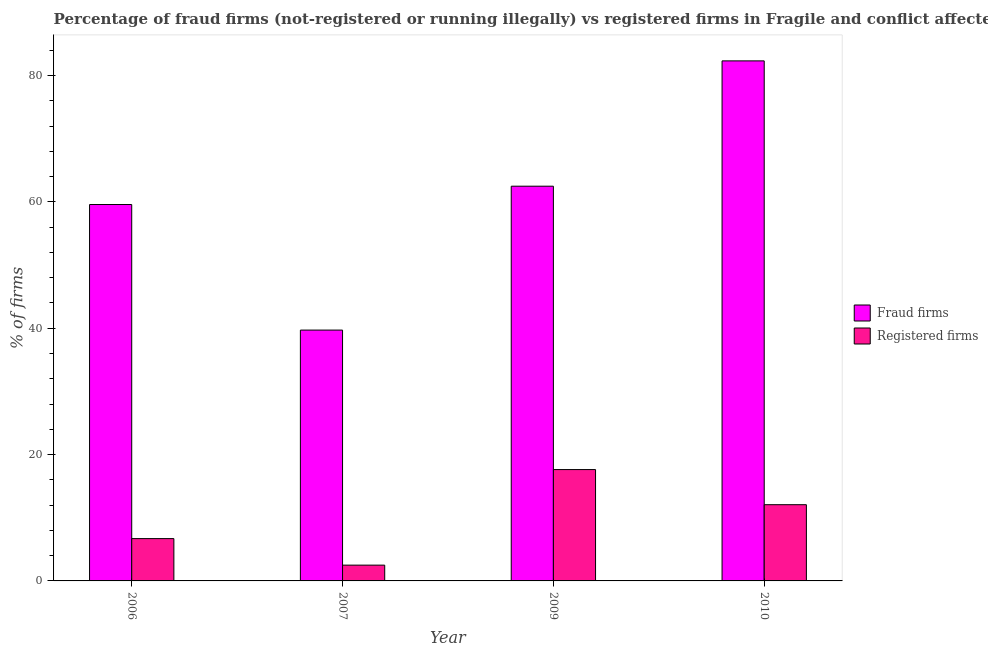How many groups of bars are there?
Provide a succinct answer. 4. Are the number of bars per tick equal to the number of legend labels?
Provide a succinct answer. Yes. How many bars are there on the 1st tick from the left?
Provide a succinct answer. 2. What is the percentage of fraud firms in 2007?
Your answer should be very brief. 39.71. Across all years, what is the maximum percentage of fraud firms?
Keep it short and to the point. 82.33. Across all years, what is the minimum percentage of fraud firms?
Make the answer very short. 39.71. In which year was the percentage of registered firms maximum?
Provide a short and direct response. 2009. In which year was the percentage of fraud firms minimum?
Offer a very short reply. 2007. What is the total percentage of fraud firms in the graph?
Give a very brief answer. 244.12. What is the difference between the percentage of registered firms in 2007 and that in 2010?
Give a very brief answer. -9.57. What is the difference between the percentage of registered firms in 2009 and the percentage of fraud firms in 2006?
Your response must be concise. 10.93. What is the average percentage of fraud firms per year?
Your answer should be compact. 61.03. In the year 2007, what is the difference between the percentage of fraud firms and percentage of registered firms?
Provide a succinct answer. 0. In how many years, is the percentage of fraud firms greater than 60 %?
Offer a terse response. 2. What is the ratio of the percentage of registered firms in 2006 to that in 2010?
Keep it short and to the point. 0.56. What is the difference between the highest and the second highest percentage of fraud firms?
Offer a very short reply. 19.84. What is the difference between the highest and the lowest percentage of fraud firms?
Your response must be concise. 42.62. In how many years, is the percentage of fraud firms greater than the average percentage of fraud firms taken over all years?
Keep it short and to the point. 2. Is the sum of the percentage of fraud firms in 2006 and 2009 greater than the maximum percentage of registered firms across all years?
Give a very brief answer. Yes. What does the 2nd bar from the left in 2010 represents?
Your answer should be compact. Registered firms. What does the 2nd bar from the right in 2007 represents?
Keep it short and to the point. Fraud firms. How many years are there in the graph?
Your answer should be very brief. 4. Are the values on the major ticks of Y-axis written in scientific E-notation?
Provide a succinct answer. No. Does the graph contain any zero values?
Make the answer very short. No. What is the title of the graph?
Your response must be concise. Percentage of fraud firms (not-registered or running illegally) vs registered firms in Fragile and conflict affected situations. Does "Commercial service exports" appear as one of the legend labels in the graph?
Offer a very short reply. No. What is the label or title of the Y-axis?
Offer a very short reply. % of firms. What is the % of firms in Fraud firms in 2006?
Keep it short and to the point. 59.59. What is the % of firms of Fraud firms in 2007?
Your response must be concise. 39.71. What is the % of firms of Registered firms in 2007?
Your answer should be compact. 2.5. What is the % of firms in Fraud firms in 2009?
Provide a succinct answer. 62.49. What is the % of firms in Registered firms in 2009?
Provide a succinct answer. 17.63. What is the % of firms of Fraud firms in 2010?
Your answer should be very brief. 82.33. What is the % of firms of Registered firms in 2010?
Your response must be concise. 12.07. Across all years, what is the maximum % of firms of Fraud firms?
Your answer should be very brief. 82.33. Across all years, what is the maximum % of firms in Registered firms?
Your answer should be compact. 17.63. Across all years, what is the minimum % of firms of Fraud firms?
Offer a very short reply. 39.71. Across all years, what is the minimum % of firms in Registered firms?
Your answer should be very brief. 2.5. What is the total % of firms of Fraud firms in the graph?
Offer a very short reply. 244.12. What is the total % of firms of Registered firms in the graph?
Make the answer very short. 38.89. What is the difference between the % of firms of Fraud firms in 2006 and that in 2007?
Provide a succinct answer. 19.88. What is the difference between the % of firms of Fraud firms in 2006 and that in 2009?
Provide a succinct answer. -2.9. What is the difference between the % of firms in Registered firms in 2006 and that in 2009?
Offer a terse response. -10.93. What is the difference between the % of firms of Fraud firms in 2006 and that in 2010?
Make the answer very short. -22.74. What is the difference between the % of firms of Registered firms in 2006 and that in 2010?
Your answer should be compact. -5.37. What is the difference between the % of firms in Fraud firms in 2007 and that in 2009?
Your answer should be very brief. -22.78. What is the difference between the % of firms of Registered firms in 2007 and that in 2009?
Keep it short and to the point. -15.13. What is the difference between the % of firms of Fraud firms in 2007 and that in 2010?
Your answer should be compact. -42.62. What is the difference between the % of firms of Registered firms in 2007 and that in 2010?
Give a very brief answer. -9.57. What is the difference between the % of firms in Fraud firms in 2009 and that in 2010?
Ensure brevity in your answer.  -19.84. What is the difference between the % of firms in Registered firms in 2009 and that in 2010?
Your answer should be compact. 5.56. What is the difference between the % of firms of Fraud firms in 2006 and the % of firms of Registered firms in 2007?
Make the answer very short. 57.09. What is the difference between the % of firms of Fraud firms in 2006 and the % of firms of Registered firms in 2009?
Your answer should be compact. 41.96. What is the difference between the % of firms in Fraud firms in 2006 and the % of firms in Registered firms in 2010?
Your response must be concise. 47.52. What is the difference between the % of firms of Fraud firms in 2007 and the % of firms of Registered firms in 2009?
Your response must be concise. 22.08. What is the difference between the % of firms in Fraud firms in 2007 and the % of firms in Registered firms in 2010?
Your response must be concise. 27.64. What is the difference between the % of firms in Fraud firms in 2009 and the % of firms in Registered firms in 2010?
Your answer should be very brief. 50.42. What is the average % of firms in Fraud firms per year?
Your answer should be compact. 61.03. What is the average % of firms in Registered firms per year?
Give a very brief answer. 9.72. In the year 2006, what is the difference between the % of firms of Fraud firms and % of firms of Registered firms?
Offer a very short reply. 52.89. In the year 2007, what is the difference between the % of firms of Fraud firms and % of firms of Registered firms?
Your answer should be compact. 37.21. In the year 2009, what is the difference between the % of firms of Fraud firms and % of firms of Registered firms?
Offer a very short reply. 44.86. In the year 2010, what is the difference between the % of firms in Fraud firms and % of firms in Registered firms?
Keep it short and to the point. 70.26. What is the ratio of the % of firms in Fraud firms in 2006 to that in 2007?
Offer a very short reply. 1.5. What is the ratio of the % of firms in Registered firms in 2006 to that in 2007?
Your response must be concise. 2.68. What is the ratio of the % of firms of Fraud firms in 2006 to that in 2009?
Provide a short and direct response. 0.95. What is the ratio of the % of firms in Registered firms in 2006 to that in 2009?
Your answer should be compact. 0.38. What is the ratio of the % of firms in Fraud firms in 2006 to that in 2010?
Give a very brief answer. 0.72. What is the ratio of the % of firms in Registered firms in 2006 to that in 2010?
Ensure brevity in your answer.  0.56. What is the ratio of the % of firms in Fraud firms in 2007 to that in 2009?
Make the answer very short. 0.64. What is the ratio of the % of firms of Registered firms in 2007 to that in 2009?
Make the answer very short. 0.14. What is the ratio of the % of firms of Fraud firms in 2007 to that in 2010?
Your response must be concise. 0.48. What is the ratio of the % of firms of Registered firms in 2007 to that in 2010?
Give a very brief answer. 0.21. What is the ratio of the % of firms of Fraud firms in 2009 to that in 2010?
Offer a very short reply. 0.76. What is the ratio of the % of firms of Registered firms in 2009 to that in 2010?
Make the answer very short. 1.46. What is the difference between the highest and the second highest % of firms of Fraud firms?
Provide a succinct answer. 19.84. What is the difference between the highest and the second highest % of firms of Registered firms?
Your response must be concise. 5.56. What is the difference between the highest and the lowest % of firms of Fraud firms?
Your answer should be very brief. 42.62. What is the difference between the highest and the lowest % of firms in Registered firms?
Make the answer very short. 15.13. 